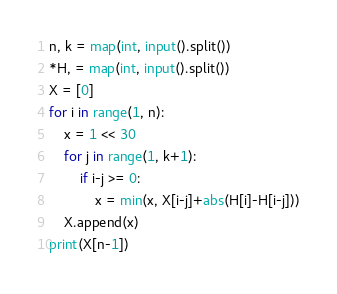Convert code to text. <code><loc_0><loc_0><loc_500><loc_500><_Python_>n, k = map(int, input().split())
*H, = map(int, input().split())
X = [0]
for i in range(1, n):
    x = 1 << 30
    for j in range(1, k+1):
        if i-j >= 0:
            x = min(x, X[i-j]+abs(H[i]-H[i-j]))
    X.append(x)
print(X[n-1])
</code> 